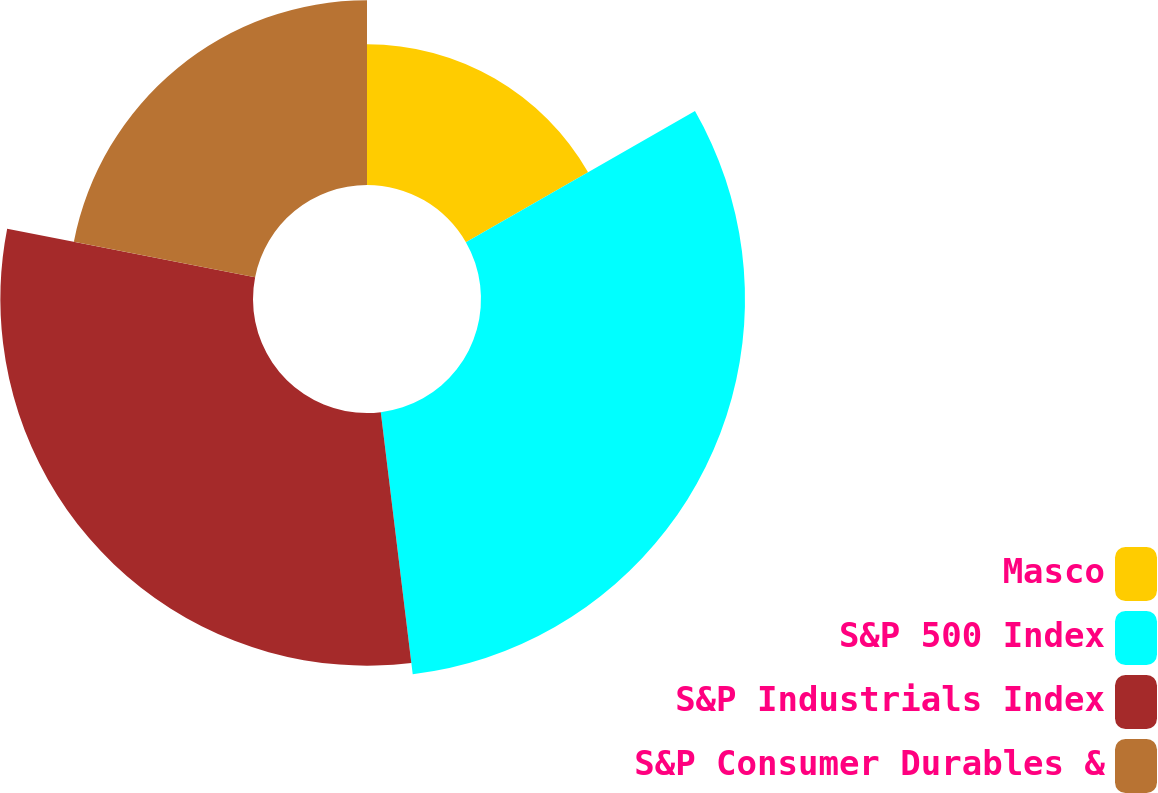<chart> <loc_0><loc_0><loc_500><loc_500><pie_chart><fcel>Masco<fcel>S&P 500 Index<fcel>S&P Industrials Index<fcel>S&P Consumer Durables &<nl><fcel>16.72%<fcel>31.35%<fcel>30.0%<fcel>21.93%<nl></chart> 